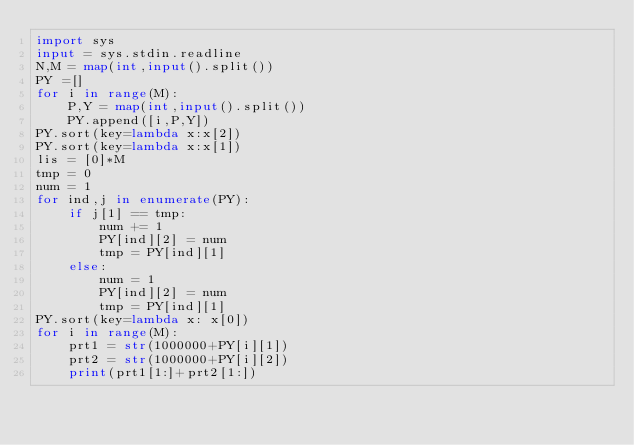Convert code to text. <code><loc_0><loc_0><loc_500><loc_500><_Python_>import sys
input = sys.stdin.readline
N,M = map(int,input().split())
PY =[]
for i in range(M):
    P,Y = map(int,input().split())
    PY.append([i,P,Y])
PY.sort(key=lambda x:x[2])
PY.sort(key=lambda x:x[1])
lis = [0]*M
tmp = 0
num = 1
for ind,j in enumerate(PY):
    if j[1] == tmp:
        num += 1
        PY[ind][2] = num
        tmp = PY[ind][1]
    else:
        num = 1
        PY[ind][2] = num
        tmp = PY[ind][1]
PY.sort(key=lambda x: x[0])
for i in range(M):
    prt1 = str(1000000+PY[i][1])
    prt2 = str(1000000+PY[i][2])
    print(prt1[1:]+prt2[1:])

</code> 